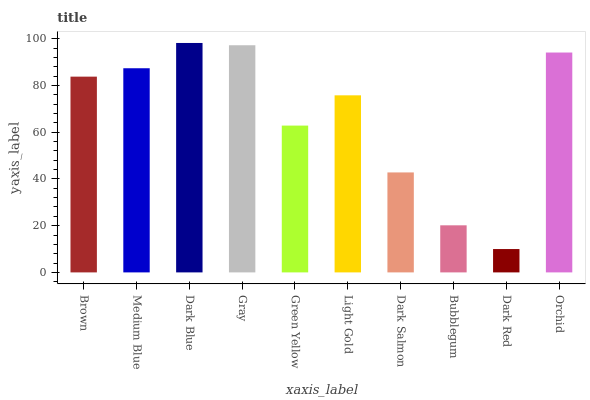Is Dark Red the minimum?
Answer yes or no. Yes. Is Dark Blue the maximum?
Answer yes or no. Yes. Is Medium Blue the minimum?
Answer yes or no. No. Is Medium Blue the maximum?
Answer yes or no. No. Is Medium Blue greater than Brown?
Answer yes or no. Yes. Is Brown less than Medium Blue?
Answer yes or no. Yes. Is Brown greater than Medium Blue?
Answer yes or no. No. Is Medium Blue less than Brown?
Answer yes or no. No. Is Brown the high median?
Answer yes or no. Yes. Is Light Gold the low median?
Answer yes or no. Yes. Is Gray the high median?
Answer yes or no. No. Is Gray the low median?
Answer yes or no. No. 